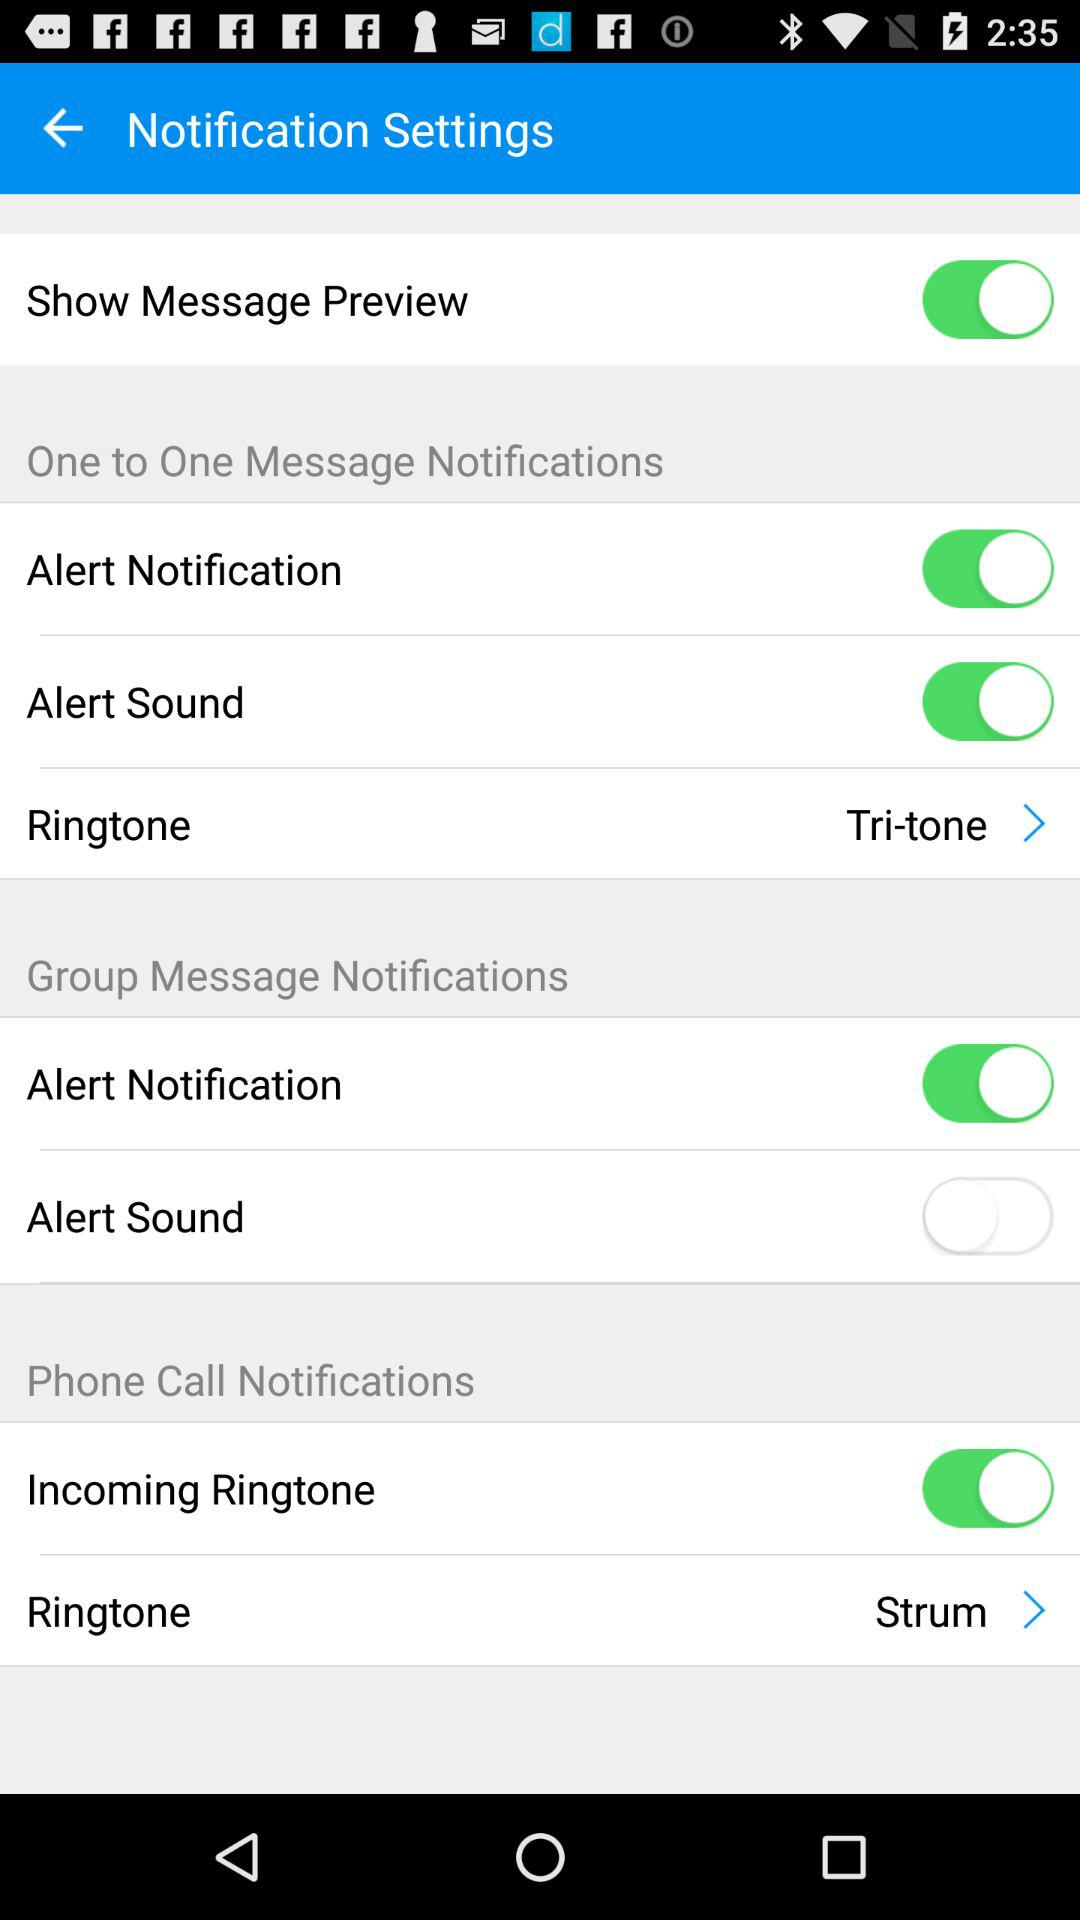What is the selected ringtone in the "One to One Message Notifications" section? The selected ringtone is "Tri-tone". 